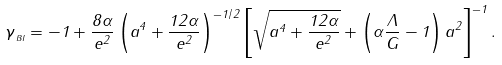Convert formula to latex. <formula><loc_0><loc_0><loc_500><loc_500>\gamma _ { \, _ { B I } } = - 1 + \frac { 8 \alpha } { e ^ { 2 } } \left ( a ^ { 4 } + \frac { 1 2 \alpha } { e ^ { 2 } } \right ) ^ { - 1 / 2 } \left [ \sqrt { a ^ { 4 } + \frac { 1 2 \alpha } { e ^ { 2 } } } + \left ( \alpha \frac { \Lambda } { G } - 1 \right ) a ^ { 2 } \right ] ^ { - 1 } .</formula> 